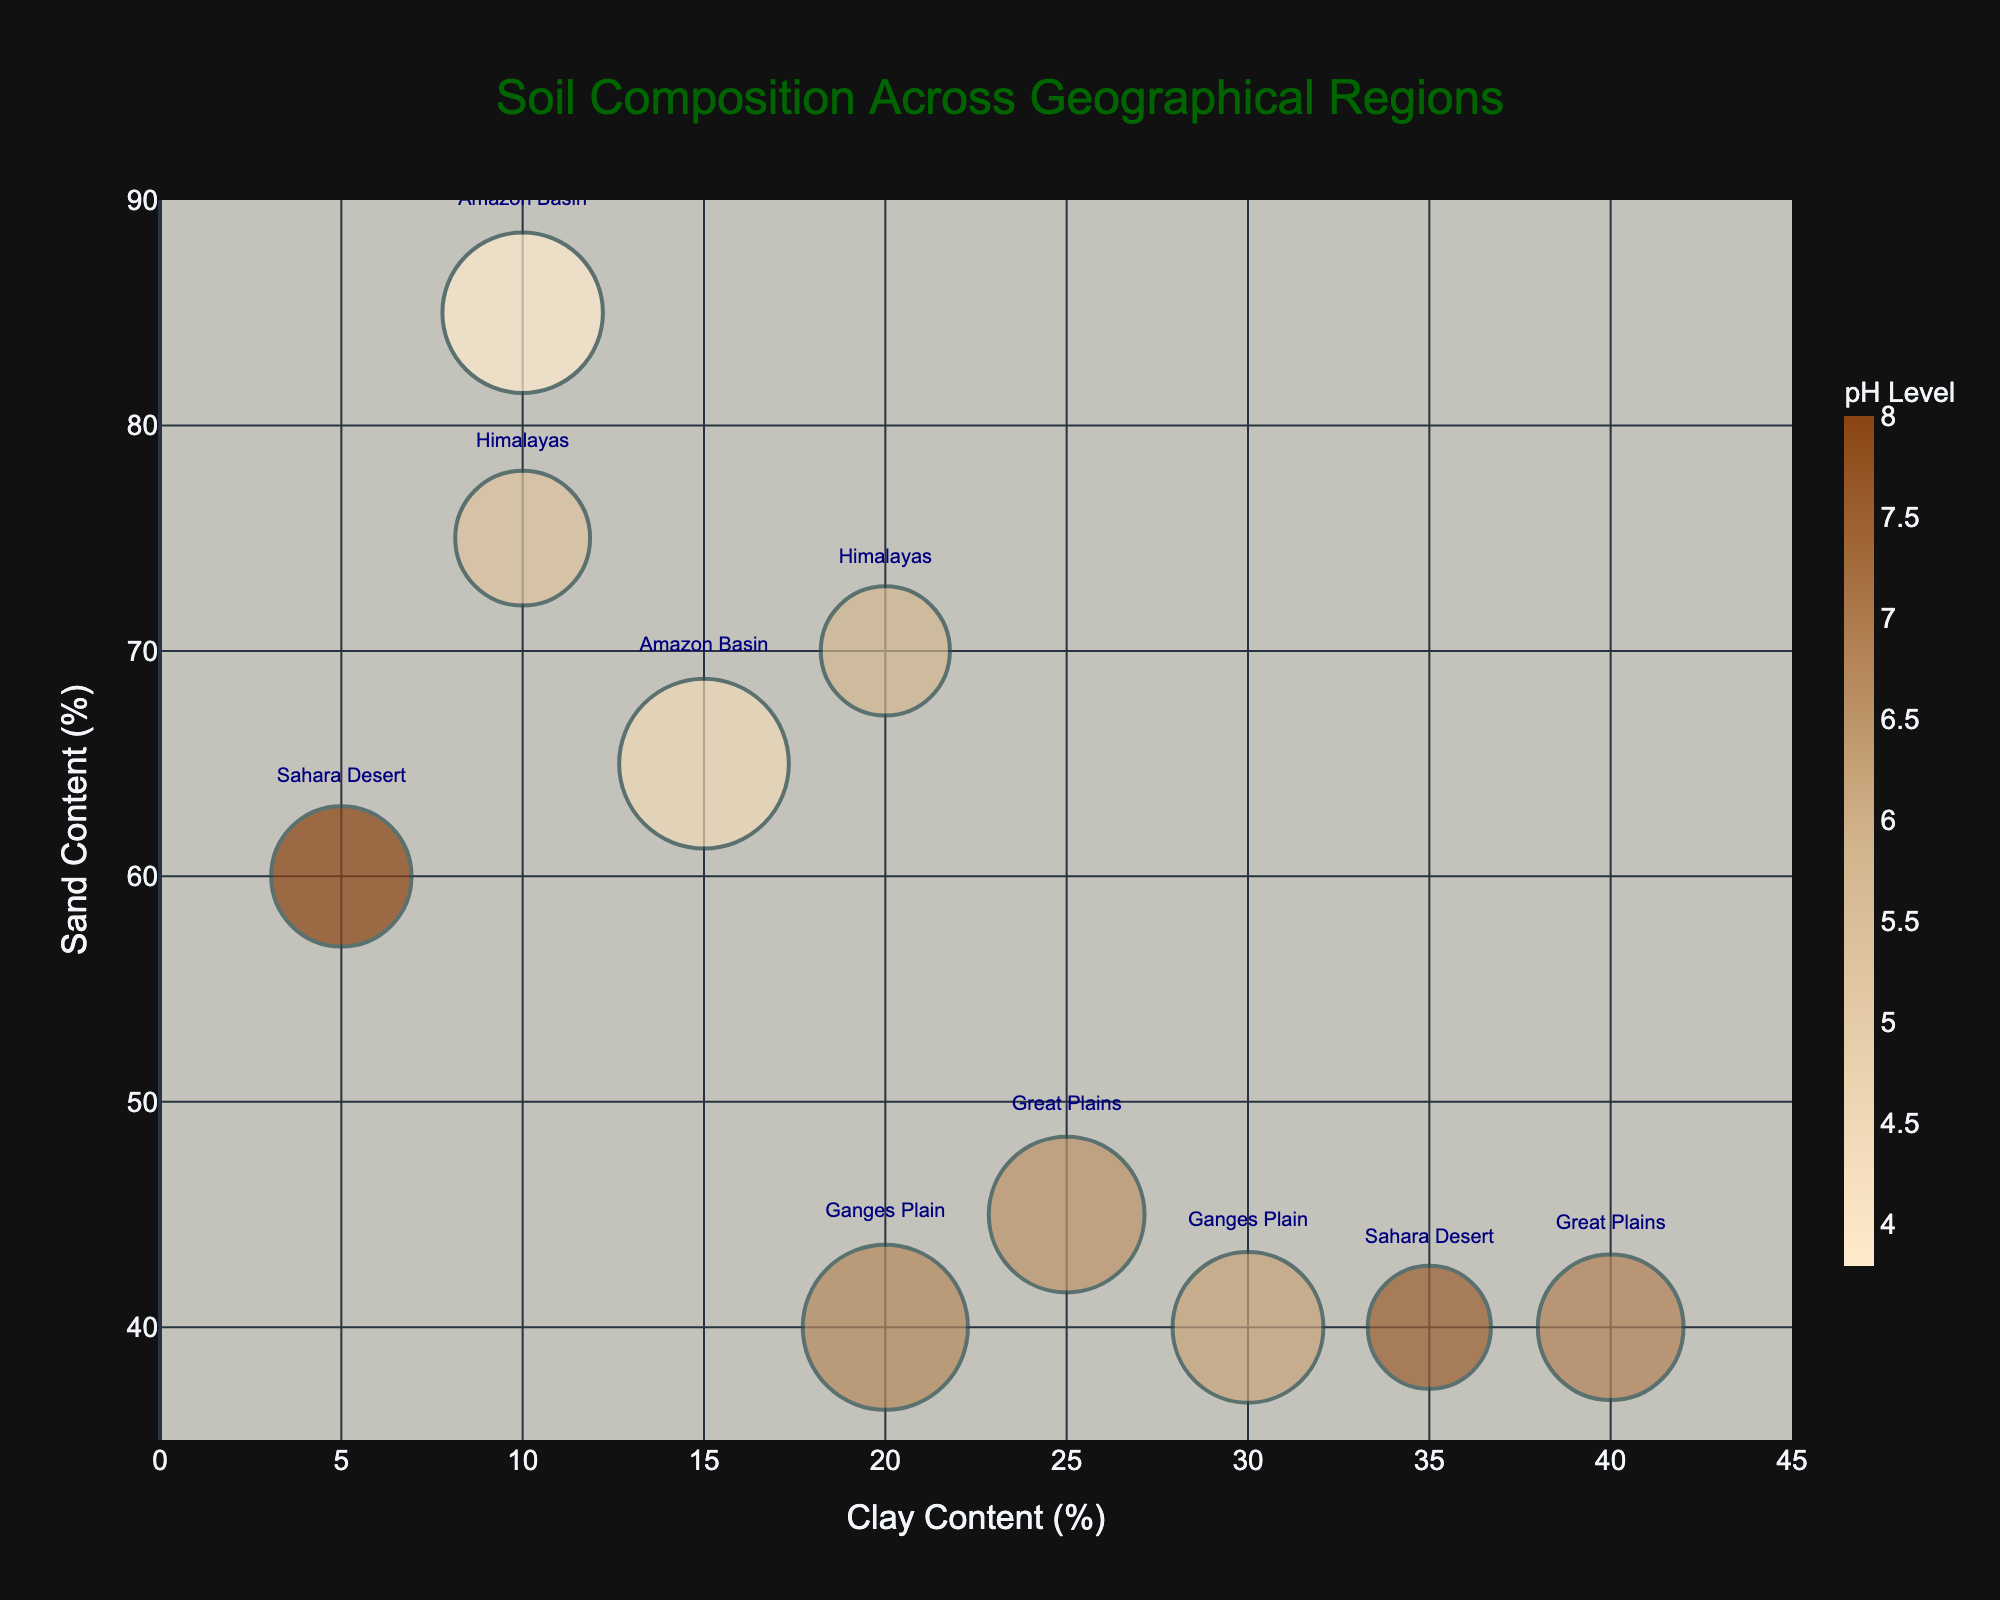How many regions are represented in the figure? Count the distinct labels shown in the texts on the bubble chart. The labels are "Great Plains," "Amazon Basin," "Sahara Desert," "Himalayas," and "Ganges Plain." Therefore, there are 5 different regions depicted.
Answer: 5 Which soil type has the highest Bubble Size, and what is its size? Identify the bubble with the largest size by observing the sizes of the bubbles in the chart. The 'Amazon Basin' region's 'Sandy Loam' soil type has the largest bubble size of 95.
Answer: Sandy Loam, 95 What is the pH range of the soils presented in the figure? Locate the color bar that represents the pH level and note the range of values indicated. The pH range is from 3.8 to 8.0.
Answer: 3.8 to 8.0 For the 'Amazon Basin' region, which soil type has higher Sand Content (%), and what is the value? Compare the sand content % of the 'Sandy Loam' and 'Peat' soil types within the 'Amazon Basin' region by looking at the y-values of the bubbles. The 'Peat' soil type has higher Sand Content of 85%.
Answer: Peat, 85% Compare the Clay Content (%) for 'Clay Loam' in the 'Sahara Desert' and 'Loam' in the 'Great Plains.' Which one is higher and by how much? Identify and compare the x-values (Clay Content %) for 'Clay Loam' in 'Sahara Desert' (35%) and 'Loam' in 'Great Plains' (25%). The Clay Content for 'Clay Loam' in 'Sahara Desert' is higher by 10%.
Answer: 'Clay Loam' in 'Sahara Desert', 10% What is the average Sand Content (%) of all soil types? Sum the Sand Content (%) of all soil types present in the figure and divide by the number of soil types. (45 + 40 + 65 + 85 + 60 + 40 + 75 + 70 + 40 + 40) / 10 = 560 / 10 = 56%
Answer: 56% Which soil type has the highest Soil Moisture (%)? By referring to the hover information or the plotted data points, identify the soil type with the highest Soil Moisture percentage. The 'Peaty Soil' in the Himalayas has the highest Soil Moisture of 50%.
Answer: Peaty Soil Does 'Alluvial Soil' have a higher or lower Clay Content (%) than 'Black Soil'? Compare the x-values for 'Alluvial Soil' and 'Black Soil' in the 'Ganges Plain' region. 'Alluvial Soil' has 20% Clay Content, whereas 'Black Soil' has 30%. Therefore, 'Alluvial Soil' has a lower Clay Content.
Answer: Lower What is the median Organic Matter Content (%) across all regions? Organize the Organic Matter Content (%) values and determine the median: [0.5, 0.8, 1.5, 2.0, 2.5, 3.0, 3.5, 4.5, 6.0, 8.0]. The median value, which is the midpoint in the sorted list or average of the 5th and 6th values, is 2.75%.
Answer: 2.75% 